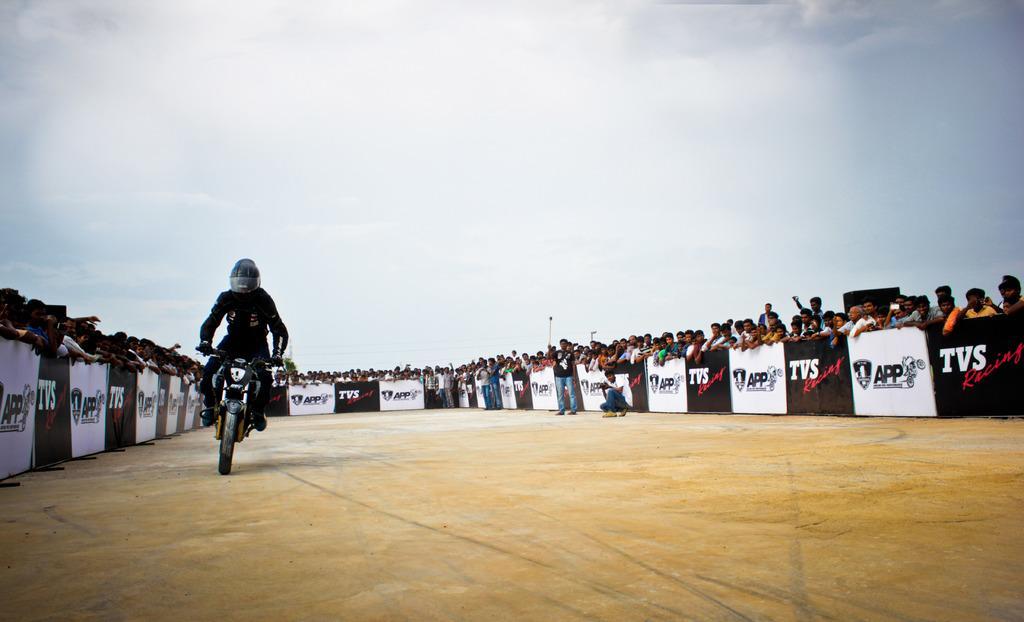Describe this image in one or two sentences. In this picture I can see there is a man riding a two wheeler and he is wearing a black shirt and a pant and helmet. In the backdrop there are few banners and there is a person sitting on to right and clicking the pictures and there is another person standing next to him. There are a group of people standing around the banners. 